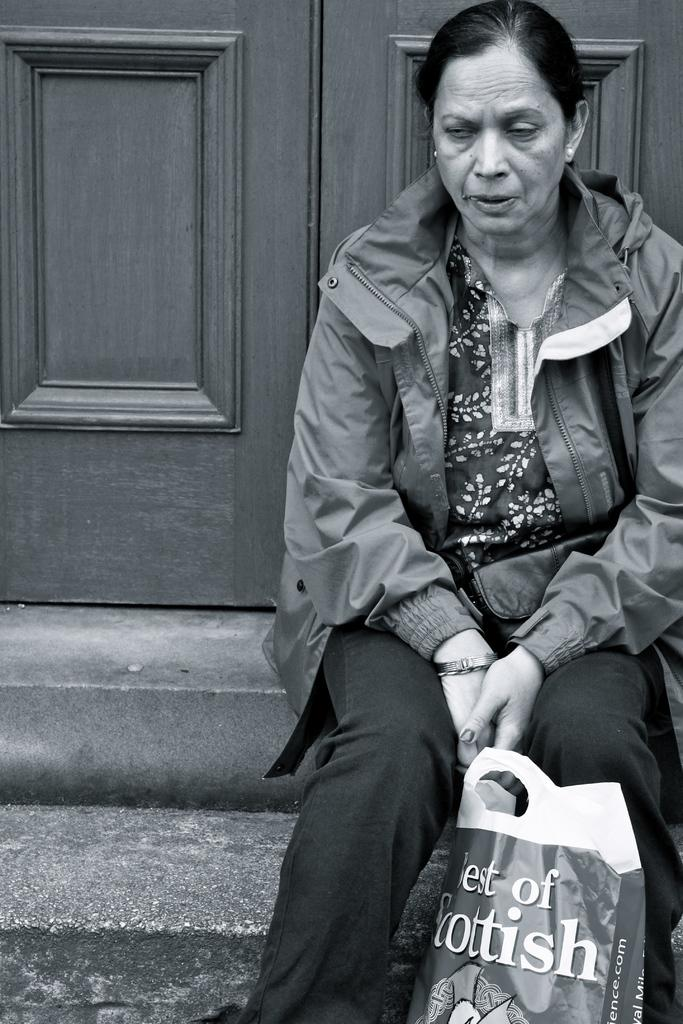What is the color scheme of the image? The image is black and white. What can be seen in the background of the image? There is a person sitting in front of a door. What object is visible in the foreground of the image? There is a polythene bag in the front. What type of clothing is the person wearing? The person is wearing a jacket. What type of brake system can be seen on the person's jacket in the image? There is no brake system visible on the person's jacket in the image. What type of trade is being conducted in the image? There is no indication of any trade being conducted in the image. 